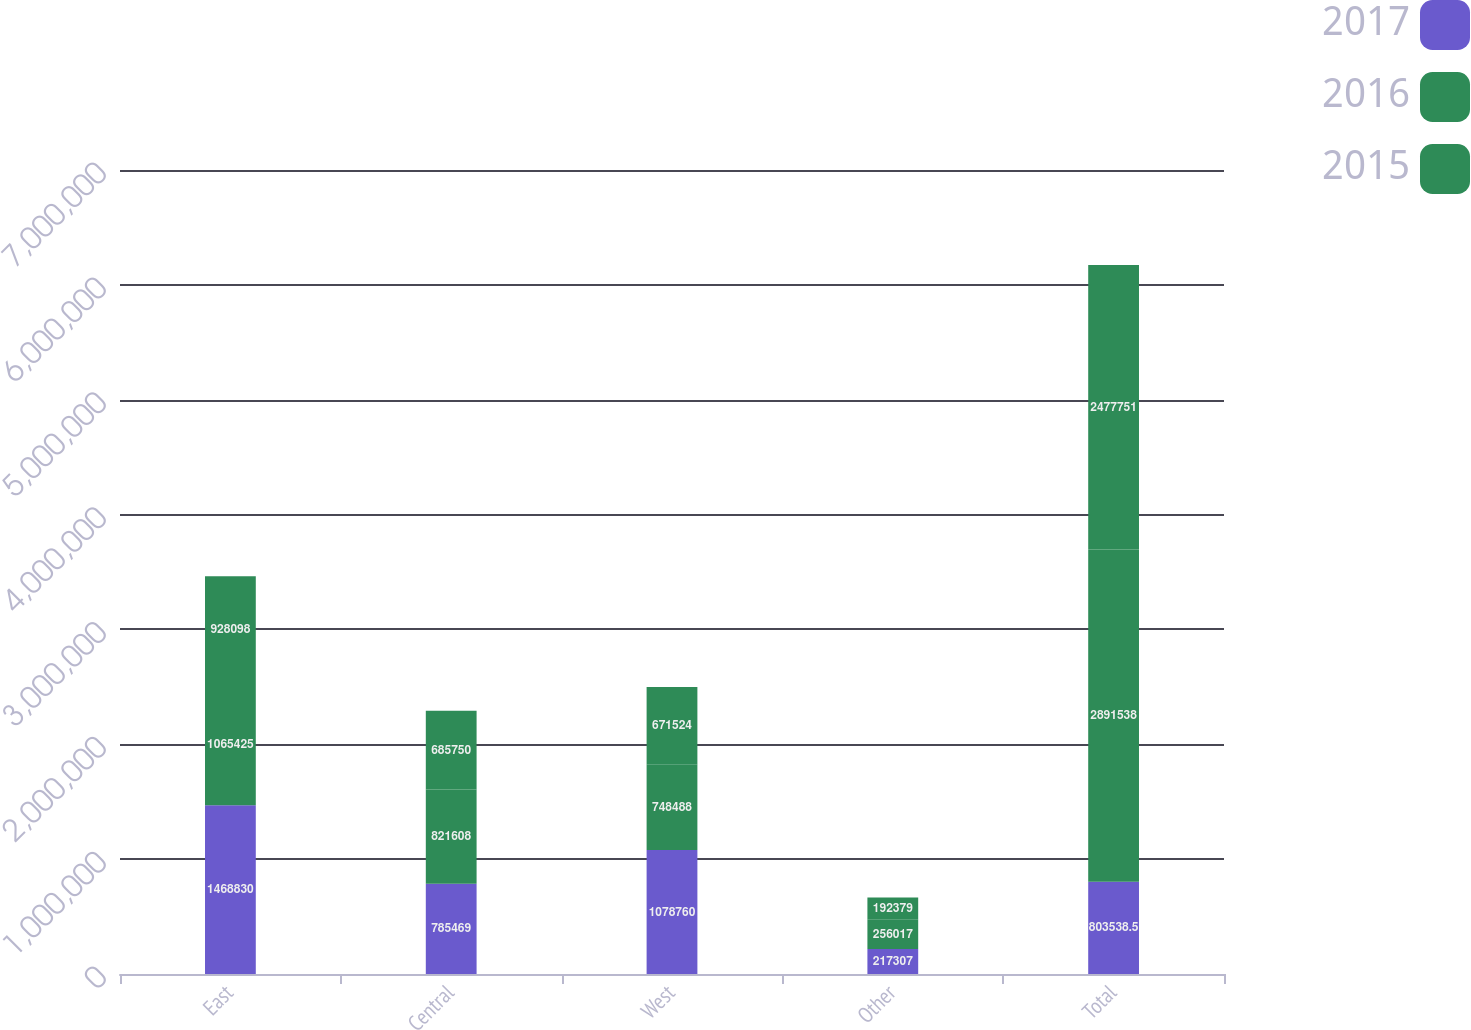Convert chart. <chart><loc_0><loc_0><loc_500><loc_500><stacked_bar_chart><ecel><fcel>East<fcel>Central<fcel>West<fcel>Other<fcel>Total<nl><fcel>2017<fcel>1.46883e+06<fcel>785469<fcel>1.07876e+06<fcel>217307<fcel>803538<nl><fcel>2016<fcel>1.06542e+06<fcel>821608<fcel>748488<fcel>256017<fcel>2.89154e+06<nl><fcel>2015<fcel>928098<fcel>685750<fcel>671524<fcel>192379<fcel>2.47775e+06<nl></chart> 